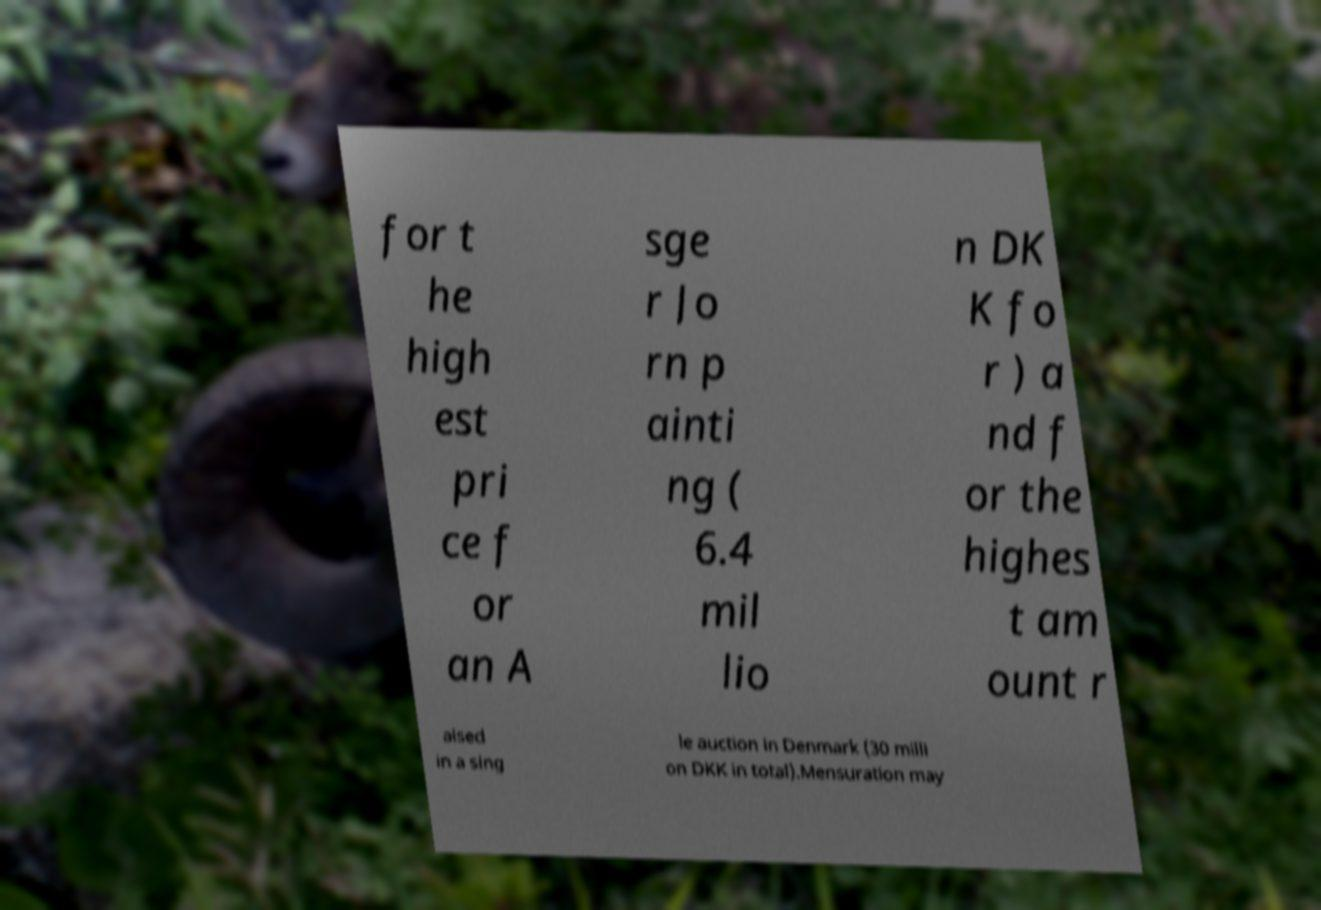There's text embedded in this image that I need extracted. Can you transcribe it verbatim? for t he high est pri ce f or an A sge r Jo rn p ainti ng ( 6.4 mil lio n DK K fo r ) a nd f or the highes t am ount r aised in a sing le auction in Denmark (30 milli on DKK in total).Mensuration may 